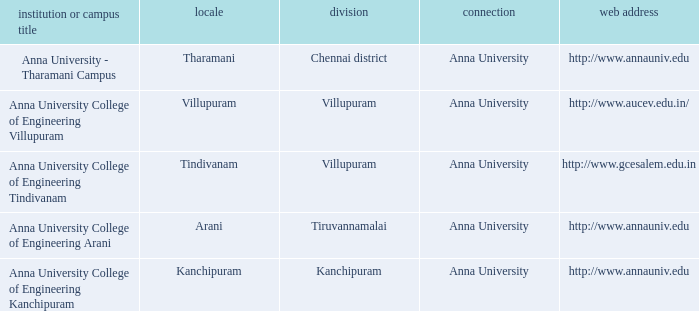What Location has a College or Campus Name of anna university - tharamani campus? Tharamani. 